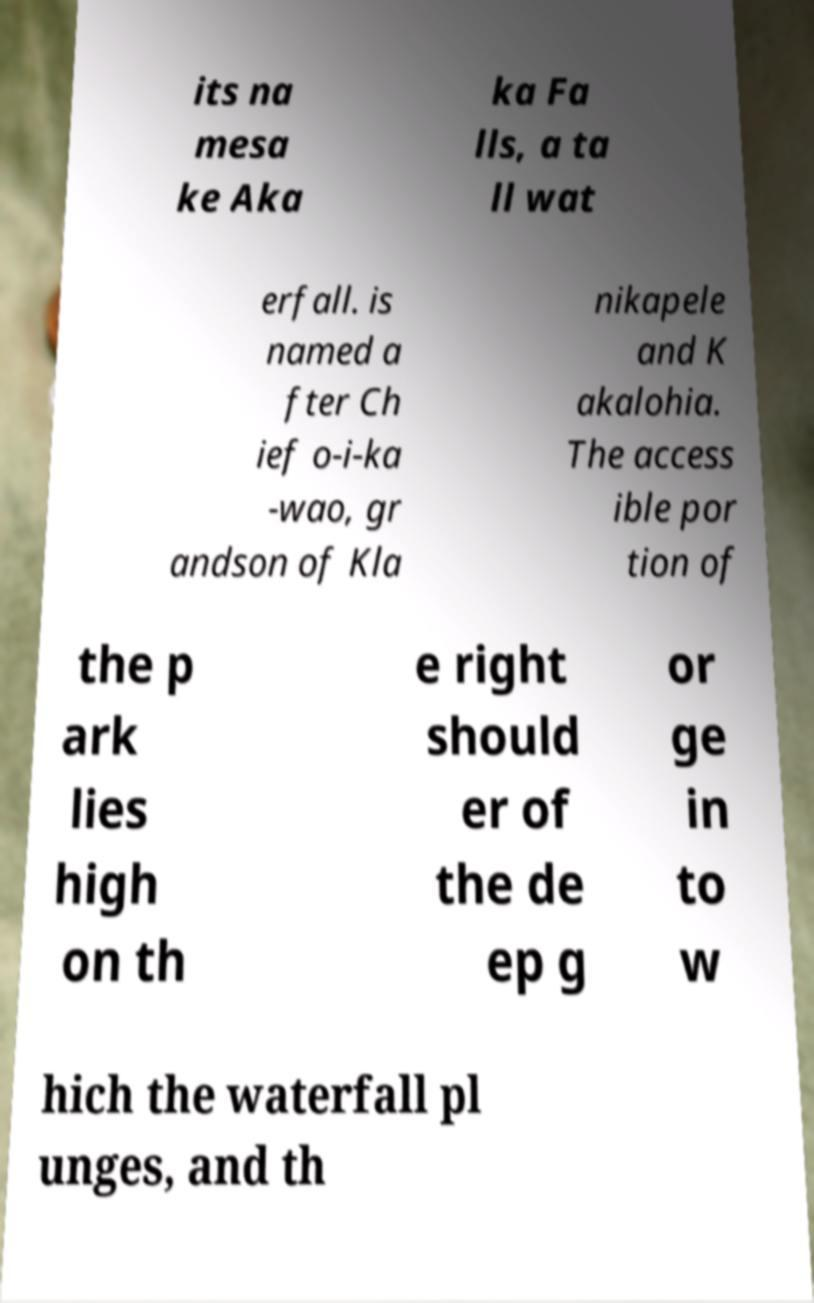Can you accurately transcribe the text from the provided image for me? its na mesa ke Aka ka Fa lls, a ta ll wat erfall. is named a fter Ch ief o-i-ka -wao, gr andson of Kla nikapele and K akalohia. The access ible por tion of the p ark lies high on th e right should er of the de ep g or ge in to w hich the waterfall pl unges, and th 